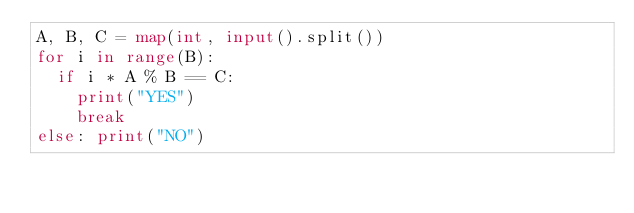<code> <loc_0><loc_0><loc_500><loc_500><_Python_>A, B, C = map(int, input().split())
for i in range(B):
  if i * A % B == C: 
    print("YES")
    break
else: print("NO")    </code> 